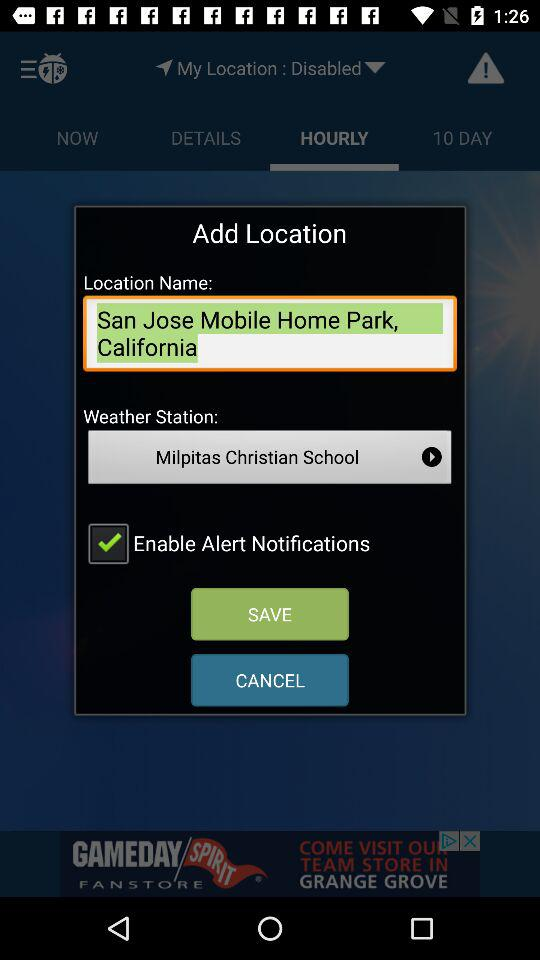What is the weather station? The weather station is Milpitas Christian School. 